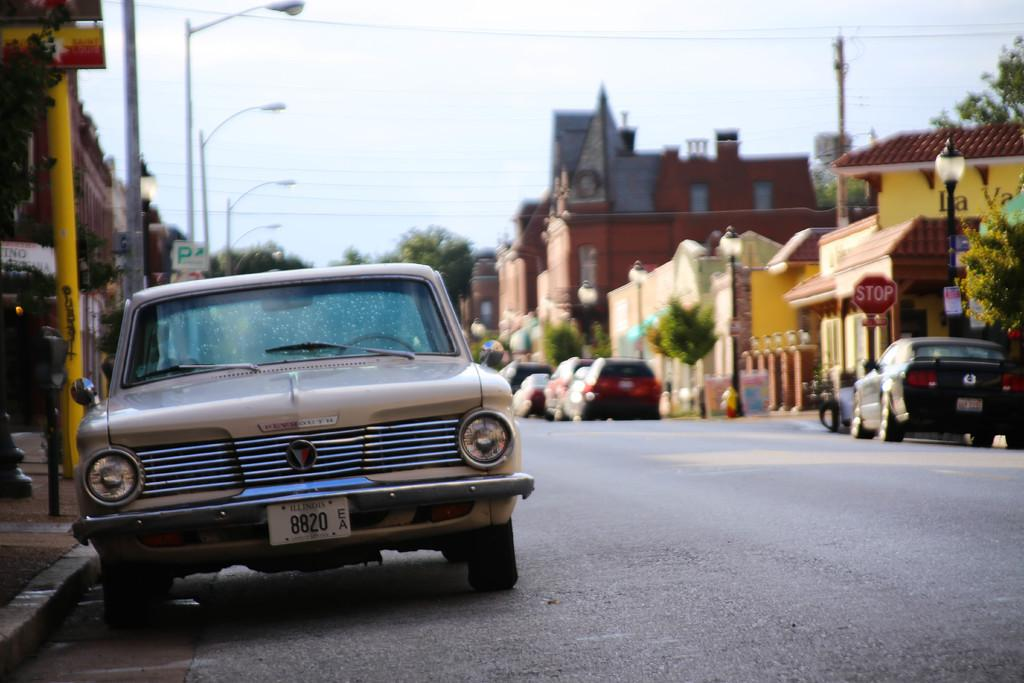What type of structures can be seen in the image? There are buildings in the image. What is happening on the road in the image? Motor vehicles are present on the road in the image. What type of vegetation is visible in the image? Trees are visible in the image. What are the vertical structures present in the image? Street poles and electric poles are present in the image. What are the lighting features in the image? Street lights are visible in the image. What is connecting the electric poles in the image? Electric cables are visible in the image. What part of the natural environment is visible in the image? The sky is visible in the image. What type of meat is being grilled in the garden in the image? There is no meat or garden present in the image; it features buildings, motor vehicles, trees, street poles, street lights, electric poles, electric cables, and the sky. What kind of pie is being served at the picnic in the image? There is no picnic or pie present in the image. 